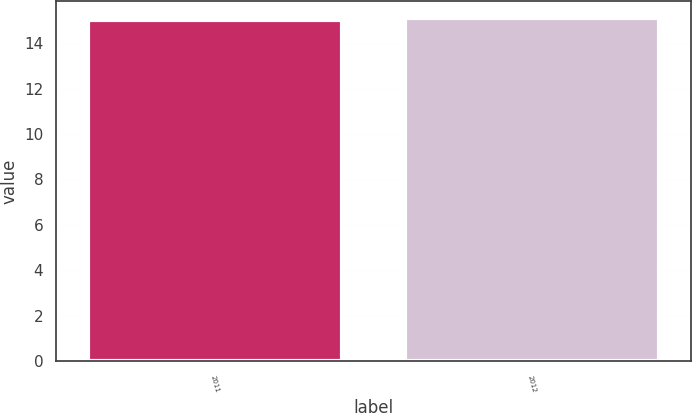Convert chart to OTSL. <chart><loc_0><loc_0><loc_500><loc_500><bar_chart><fcel>2011<fcel>2012<nl><fcel>15<fcel>15.1<nl></chart> 